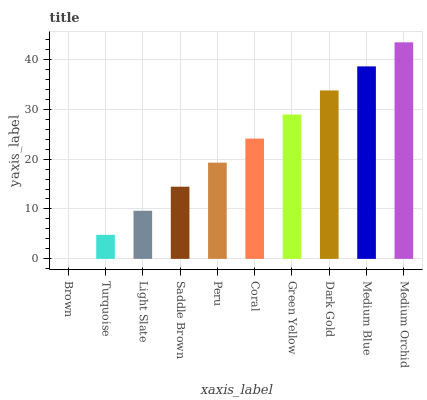Is Brown the minimum?
Answer yes or no. Yes. Is Medium Orchid the maximum?
Answer yes or no. Yes. Is Turquoise the minimum?
Answer yes or no. No. Is Turquoise the maximum?
Answer yes or no. No. Is Turquoise greater than Brown?
Answer yes or no. Yes. Is Brown less than Turquoise?
Answer yes or no. Yes. Is Brown greater than Turquoise?
Answer yes or no. No. Is Turquoise less than Brown?
Answer yes or no. No. Is Coral the high median?
Answer yes or no. Yes. Is Peru the low median?
Answer yes or no. Yes. Is Dark Gold the high median?
Answer yes or no. No. Is Brown the low median?
Answer yes or no. No. 